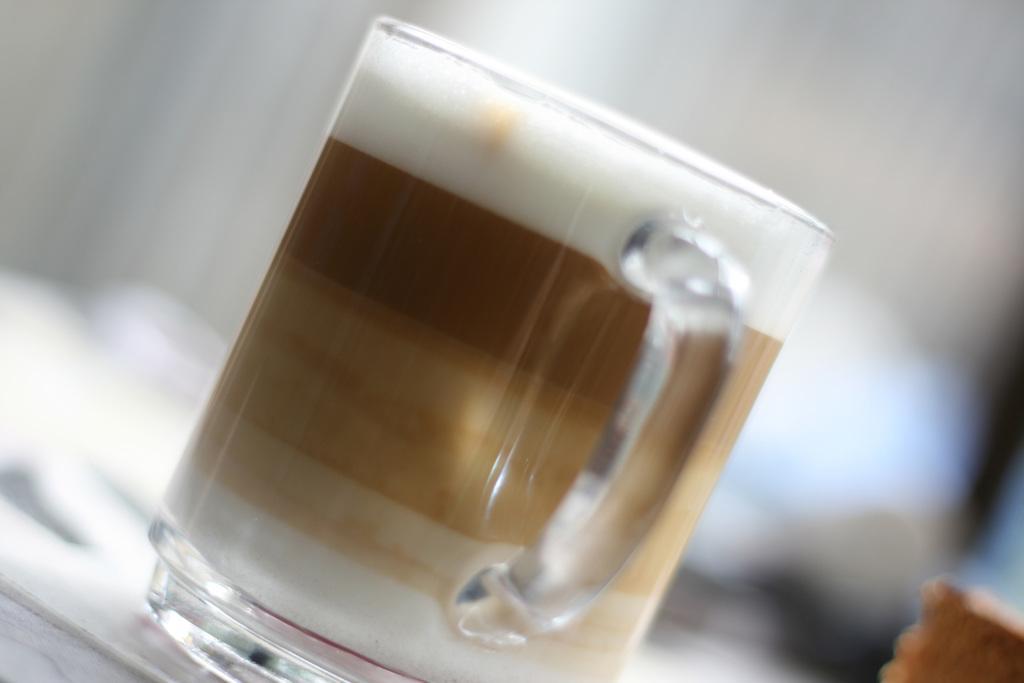Please provide a concise description of this image. In the foreground of this image, there is a mug on the white surface and the background image is blur. We can also see a brown color object in the right bottom corner. 